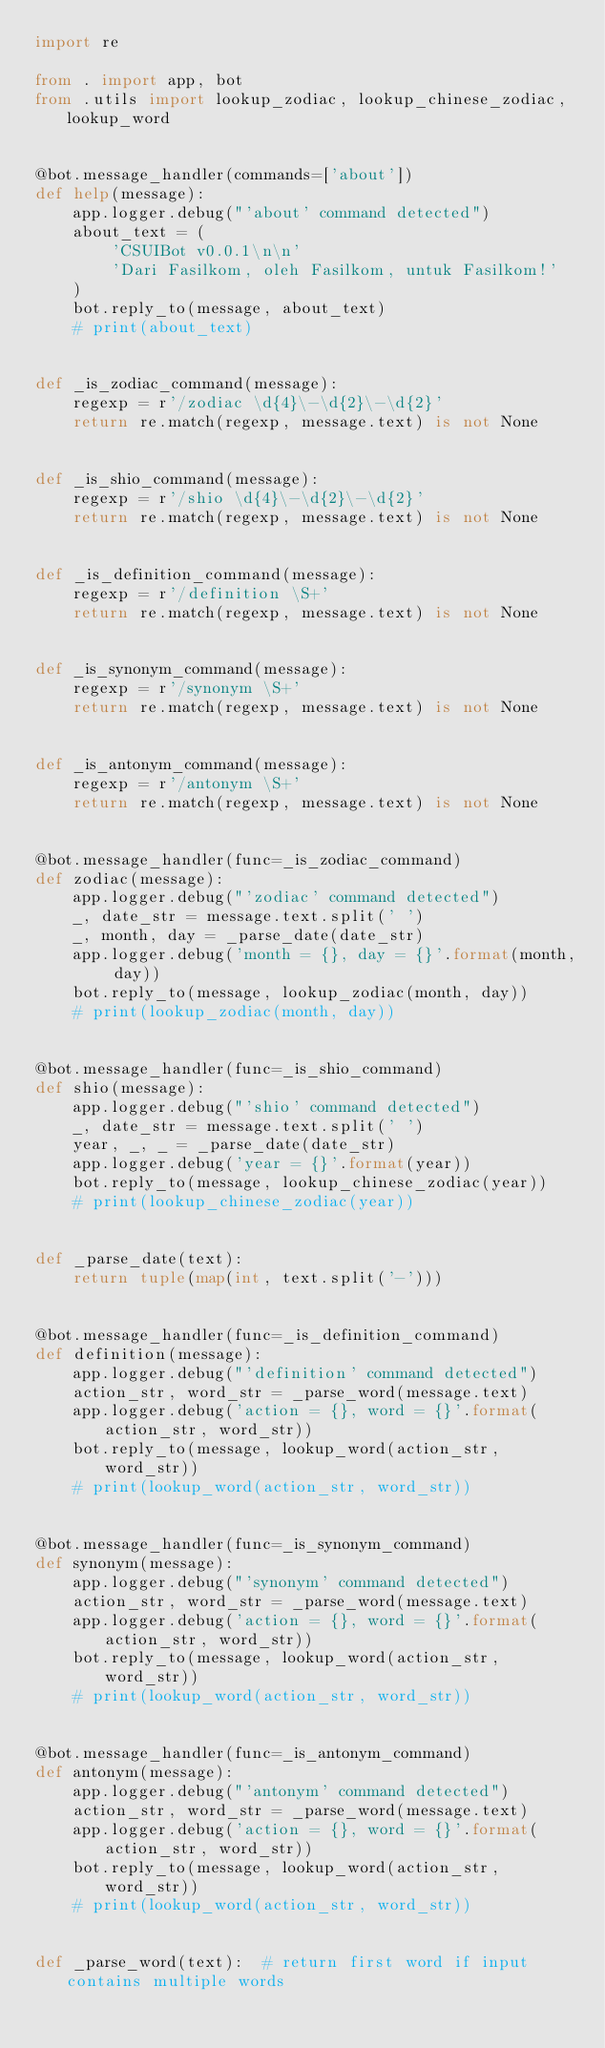<code> <loc_0><loc_0><loc_500><loc_500><_Python_>import re

from . import app, bot
from .utils import lookup_zodiac, lookup_chinese_zodiac, lookup_word


@bot.message_handler(commands=['about'])
def help(message):
    app.logger.debug("'about' command detected")
    about_text = (
        'CSUIBot v0.0.1\n\n'
        'Dari Fasilkom, oleh Fasilkom, untuk Fasilkom!'
    )
    bot.reply_to(message, about_text)
    # print(about_text)


def _is_zodiac_command(message):
    regexp = r'/zodiac \d{4}\-\d{2}\-\d{2}'
    return re.match(regexp, message.text) is not None


def _is_shio_command(message):
    regexp = r'/shio \d{4}\-\d{2}\-\d{2}'
    return re.match(regexp, message.text) is not None


def _is_definition_command(message):
    regexp = r'/definition \S+'
    return re.match(regexp, message.text) is not None


def _is_synonym_command(message):
    regexp = r'/synonym \S+'
    return re.match(regexp, message.text) is not None


def _is_antonym_command(message):
    regexp = r'/antonym \S+'
    return re.match(regexp, message.text) is not None


@bot.message_handler(func=_is_zodiac_command)
def zodiac(message):
    app.logger.debug("'zodiac' command detected")
    _, date_str = message.text.split(' ')
    _, month, day = _parse_date(date_str)
    app.logger.debug('month = {}, day = {}'.format(month, day))
    bot.reply_to(message, lookup_zodiac(month, day))
    # print(lookup_zodiac(month, day))


@bot.message_handler(func=_is_shio_command)
def shio(message):
    app.logger.debug("'shio' command detected")
    _, date_str = message.text.split(' ')
    year, _, _ = _parse_date(date_str)
    app.logger.debug('year = {}'.format(year))
    bot.reply_to(message, lookup_chinese_zodiac(year))
    # print(lookup_chinese_zodiac(year))


def _parse_date(text):
    return tuple(map(int, text.split('-')))


@bot.message_handler(func=_is_definition_command)
def definition(message):
    app.logger.debug("'definition' command detected")
    action_str, word_str = _parse_word(message.text)
    app.logger.debug('action = {}, word = {}'.format(action_str, word_str))
    bot.reply_to(message, lookup_word(action_str, word_str))
    # print(lookup_word(action_str, word_str))


@bot.message_handler(func=_is_synonym_command)
def synonym(message):
    app.logger.debug("'synonym' command detected")
    action_str, word_str = _parse_word(message.text)
    app.logger.debug('action = {}, word = {}'.format(action_str, word_str))
    bot.reply_to(message, lookup_word(action_str, word_str))
    # print(lookup_word(action_str, word_str))


@bot.message_handler(func=_is_antonym_command)
def antonym(message):
    app.logger.debug("'antonym' command detected")
    action_str, word_str = _parse_word(message.text)
    app.logger.debug('action = {}, word = {}'.format(action_str, word_str))
    bot.reply_to(message, lookup_word(action_str, word_str))
    # print(lookup_word(action_str, word_str))


def _parse_word(text):  # return first word if input contains multiple words</code> 